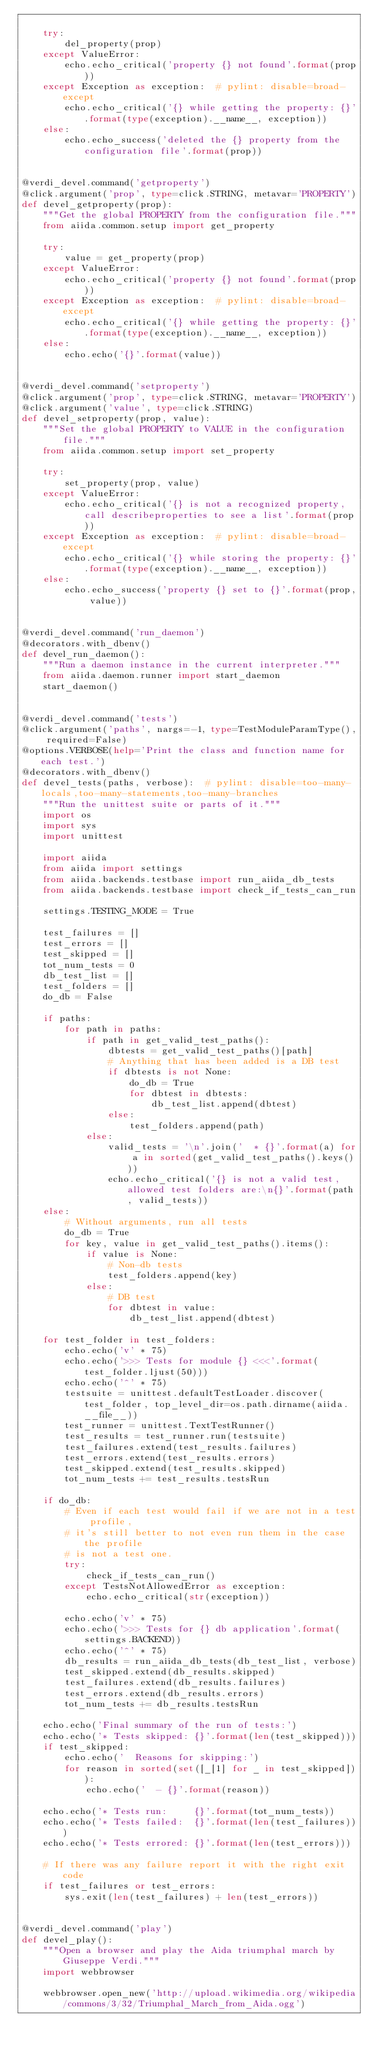Convert code to text. <code><loc_0><loc_0><loc_500><loc_500><_Python_>
    try:
        del_property(prop)
    except ValueError:
        echo.echo_critical('property {} not found'.format(prop))
    except Exception as exception:  # pylint: disable=broad-except
        echo.echo_critical('{} while getting the property: {}'.format(type(exception).__name__, exception))
    else:
        echo.echo_success('deleted the {} property from the configuration file'.format(prop))


@verdi_devel.command('getproperty')
@click.argument('prop', type=click.STRING, metavar='PROPERTY')
def devel_getproperty(prop):
    """Get the global PROPERTY from the configuration file."""
    from aiida.common.setup import get_property

    try:
        value = get_property(prop)
    except ValueError:
        echo.echo_critical('property {} not found'.format(prop))
    except Exception as exception:  # pylint: disable=broad-except
        echo.echo_critical('{} while getting the property: {}'.format(type(exception).__name__, exception))
    else:
        echo.echo('{}'.format(value))


@verdi_devel.command('setproperty')
@click.argument('prop', type=click.STRING, metavar='PROPERTY')
@click.argument('value', type=click.STRING)
def devel_setproperty(prop, value):
    """Set the global PROPERTY to VALUE in the configuration file."""
    from aiida.common.setup import set_property

    try:
        set_property(prop, value)
    except ValueError:
        echo.echo_critical('{} is not a recognized property, call describeproperties to see a list'.format(prop))
    except Exception as exception:  # pylint: disable=broad-except
        echo.echo_critical('{} while storing the property: {}'.format(type(exception).__name__, exception))
    else:
        echo.echo_success('property {} set to {}'.format(prop, value))


@verdi_devel.command('run_daemon')
@decorators.with_dbenv()
def devel_run_daemon():
    """Run a daemon instance in the current interpreter."""
    from aiida.daemon.runner import start_daemon
    start_daemon()


@verdi_devel.command('tests')
@click.argument('paths', nargs=-1, type=TestModuleParamType(), required=False)
@options.VERBOSE(help='Print the class and function name for each test.')
@decorators.with_dbenv()
def devel_tests(paths, verbose):  # pylint: disable=too-many-locals,too-many-statements,too-many-branches
    """Run the unittest suite or parts of it."""
    import os
    import sys
    import unittest

    import aiida
    from aiida import settings
    from aiida.backends.testbase import run_aiida_db_tests
    from aiida.backends.testbase import check_if_tests_can_run

    settings.TESTING_MODE = True

    test_failures = []
    test_errors = []
    test_skipped = []
    tot_num_tests = 0
    db_test_list = []
    test_folders = []
    do_db = False

    if paths:
        for path in paths:
            if path in get_valid_test_paths():
                dbtests = get_valid_test_paths()[path]
                # Anything that has been added is a DB test
                if dbtests is not None:
                    do_db = True
                    for dbtest in dbtests:
                        db_test_list.append(dbtest)
                else:
                    test_folders.append(path)
            else:
                valid_tests = '\n'.join('  * {}'.format(a) for a in sorted(get_valid_test_paths().keys()))
                echo.echo_critical('{} is not a valid test, allowed test folders are:\n{}'.format(path, valid_tests))
    else:
        # Without arguments, run all tests
        do_db = True
        for key, value in get_valid_test_paths().items():
            if value is None:
                # Non-db tests
                test_folders.append(key)
            else:
                # DB test
                for dbtest in value:
                    db_test_list.append(dbtest)

    for test_folder in test_folders:
        echo.echo('v' * 75)
        echo.echo('>>> Tests for module {} <<<'.format(test_folder.ljust(50)))
        echo.echo('^' * 75)
        testsuite = unittest.defaultTestLoader.discover(test_folder, top_level_dir=os.path.dirname(aiida.__file__))
        test_runner = unittest.TextTestRunner()
        test_results = test_runner.run(testsuite)
        test_failures.extend(test_results.failures)
        test_errors.extend(test_results.errors)
        test_skipped.extend(test_results.skipped)
        tot_num_tests += test_results.testsRun

    if do_db:
        # Even if each test would fail if we are not in a test profile,
        # it's still better to not even run them in the case the profile
        # is not a test one.
        try:
            check_if_tests_can_run()
        except TestsNotAllowedError as exception:
            echo.echo_critical(str(exception))

        echo.echo('v' * 75)
        echo.echo('>>> Tests for {} db application'.format(settings.BACKEND))
        echo.echo('^' * 75)
        db_results = run_aiida_db_tests(db_test_list, verbose)
        test_skipped.extend(db_results.skipped)
        test_failures.extend(db_results.failures)
        test_errors.extend(db_results.errors)
        tot_num_tests += db_results.testsRun

    echo.echo('Final summary of the run of tests:')
    echo.echo('* Tests skipped: {}'.format(len(test_skipped)))
    if test_skipped:
        echo.echo('  Reasons for skipping:')
        for reason in sorted(set([_[1] for _ in test_skipped])):
            echo.echo('  - {}'.format(reason))

    echo.echo('* Tests run:     {}'.format(tot_num_tests))
    echo.echo('* Tests failed:  {}'.format(len(test_failures)))
    echo.echo('* Tests errored: {}'.format(len(test_errors)))

    # If there was any failure report it with the right exit code
    if test_failures or test_errors:
        sys.exit(len(test_failures) + len(test_errors))


@verdi_devel.command('play')
def devel_play():
    """Open a browser and play the Aida triumphal march by Giuseppe Verdi."""
    import webbrowser

    webbrowser.open_new('http://upload.wikimedia.org/wikipedia/commons/3/32/Triumphal_March_from_Aida.ogg')
</code> 